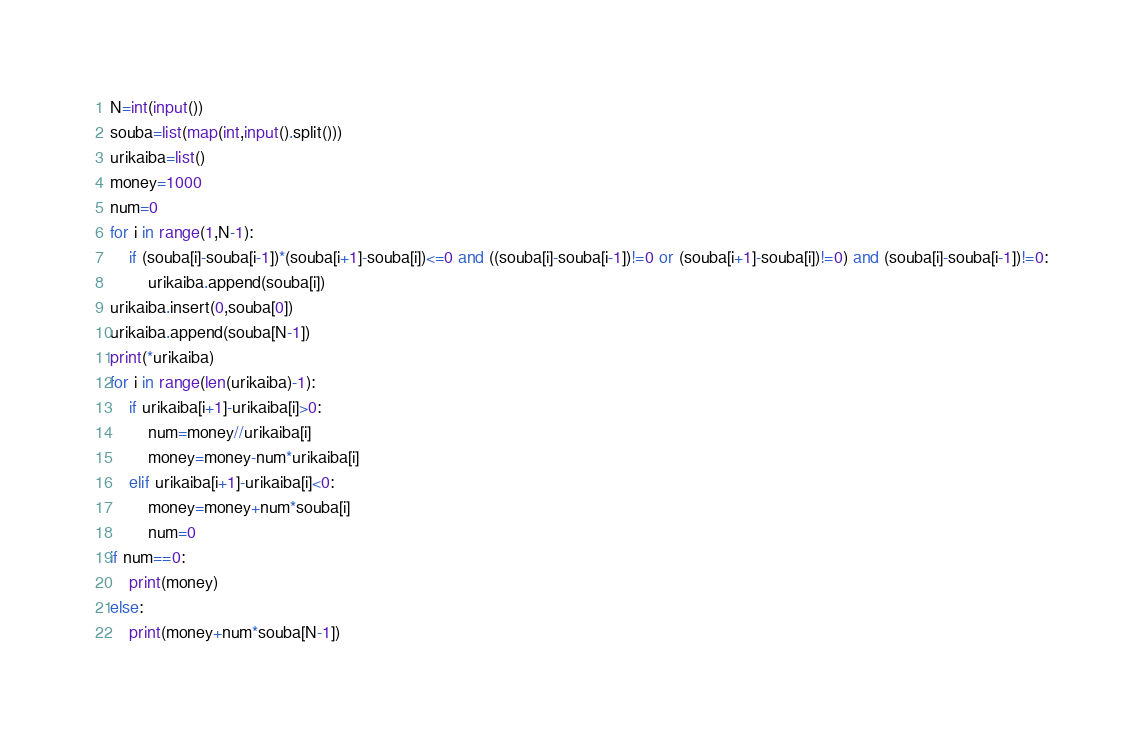<code> <loc_0><loc_0><loc_500><loc_500><_Python_>N=int(input())
souba=list(map(int,input().split()))
urikaiba=list()
money=1000
num=0
for i in range(1,N-1):
    if (souba[i]-souba[i-1])*(souba[i+1]-souba[i])<=0 and ((souba[i]-souba[i-1])!=0 or (souba[i+1]-souba[i])!=0) and (souba[i]-souba[i-1])!=0:
        urikaiba.append(souba[i])
urikaiba.insert(0,souba[0])
urikaiba.append(souba[N-1])
print(*urikaiba)
for i in range(len(urikaiba)-1):
    if urikaiba[i+1]-urikaiba[i]>0:
        num=money//urikaiba[i]
        money=money-num*urikaiba[i]
    elif urikaiba[i+1]-urikaiba[i]<0:
        money=money+num*souba[i]
        num=0
if num==0:
    print(money)
else:
    print(money+num*souba[N-1])

</code> 